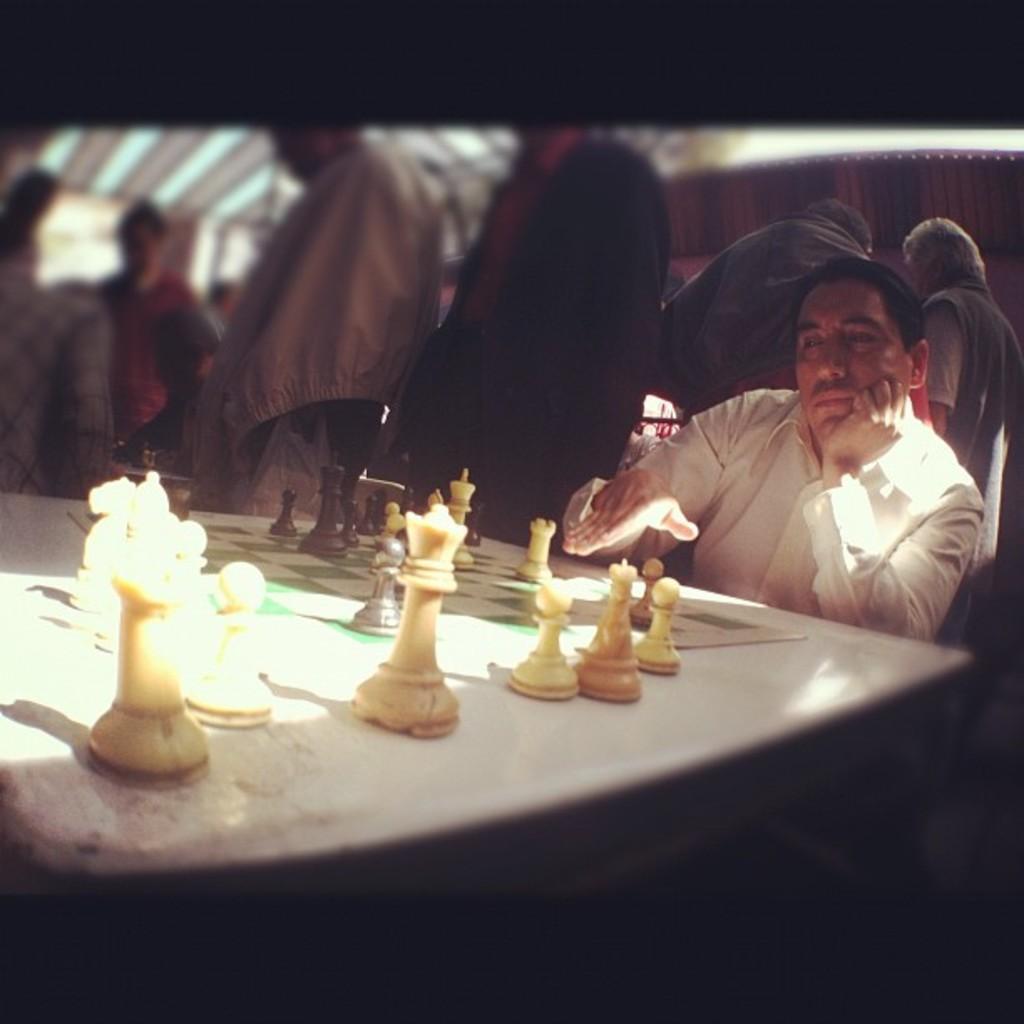Can you describe this image briefly? In the center of the image we can see one person is sitting. In front of him, we can see one table. On the table, we can see one chess board and a few other objects. In the background there is a wall, few people are standing and a few other objects. 